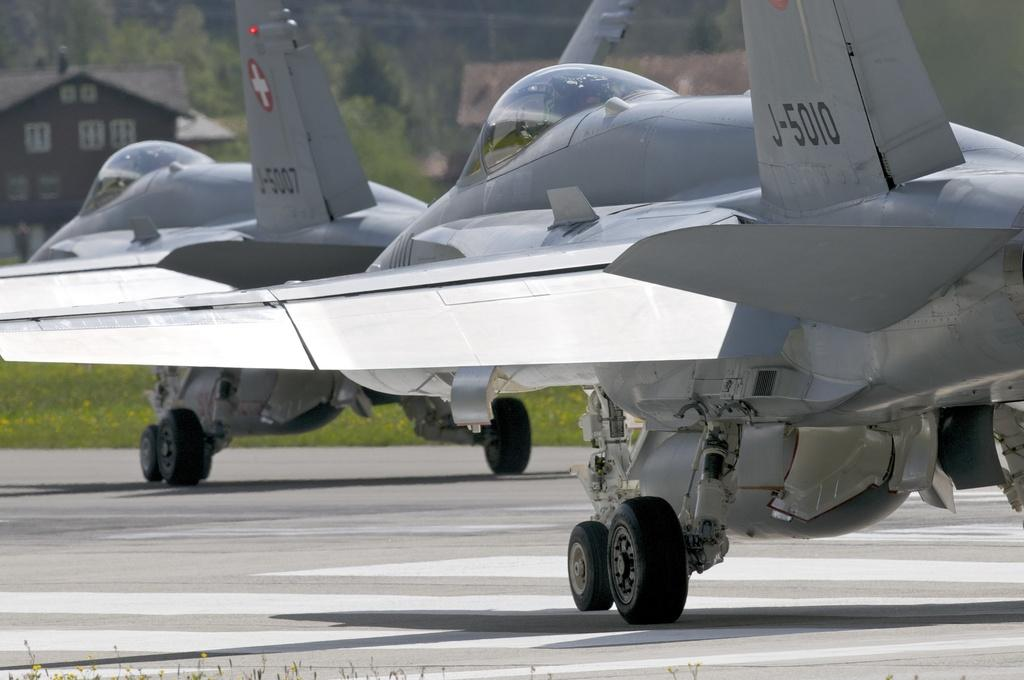What unusual objects can be seen on the road in the image? There are aeroplanes on the road in the image. What structures can be seen in the background of the image? There are sheds in the background of the image. What type of natural elements are visible in the background of the image? Trees are visible in the background of the image. What type of cemetery can be seen in the image? There is no cemetery present in the image; it features aeroplanes on the road and sheds and trees in the background. How does the spy use the aeroplanes on the road in the image? There is no spy or any indication of espionage in the image; it simply shows aeroplanes on the road. 